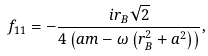<formula> <loc_0><loc_0><loc_500><loc_500>f _ { 1 1 } = - \frac { i r _ { B } \sqrt { 2 } } { { 4 \left ( { a m - \omega \left ( { r _ { B } ^ { 2 } + a ^ { 2 } } \right ) } \right ) } } ,</formula> 